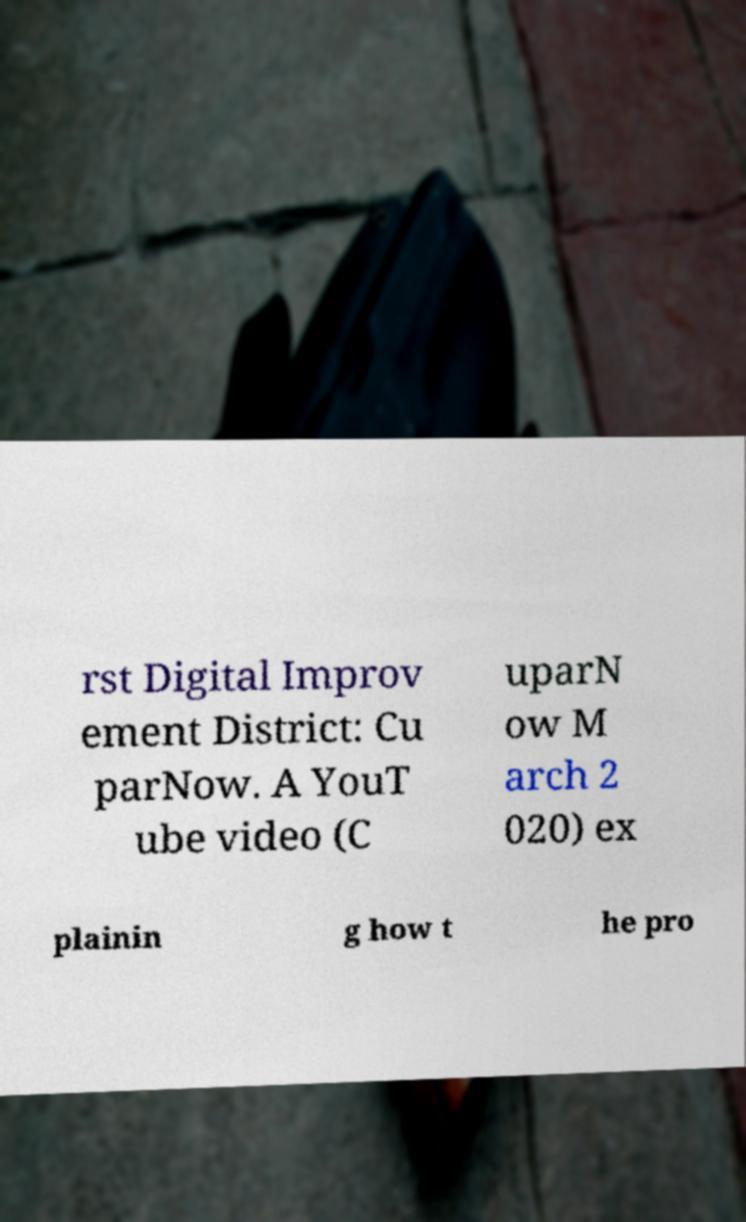Could you extract and type out the text from this image? rst Digital Improv ement District: Cu parNow. A YouT ube video (C uparN ow M arch 2 020) ex plainin g how t he pro 